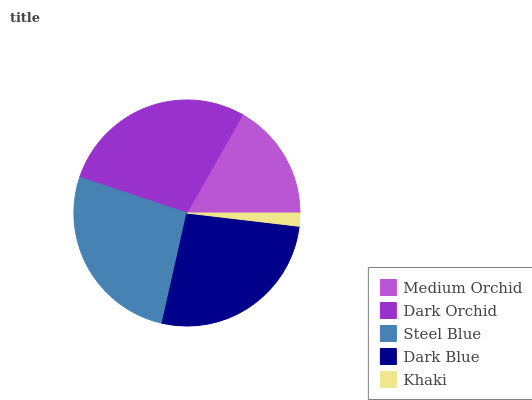Is Khaki the minimum?
Answer yes or no. Yes. Is Dark Orchid the maximum?
Answer yes or no. Yes. Is Steel Blue the minimum?
Answer yes or no. No. Is Steel Blue the maximum?
Answer yes or no. No. Is Dark Orchid greater than Steel Blue?
Answer yes or no. Yes. Is Steel Blue less than Dark Orchid?
Answer yes or no. Yes. Is Steel Blue greater than Dark Orchid?
Answer yes or no. No. Is Dark Orchid less than Steel Blue?
Answer yes or no. No. Is Steel Blue the high median?
Answer yes or no. Yes. Is Steel Blue the low median?
Answer yes or no. Yes. Is Dark Blue the high median?
Answer yes or no. No. Is Khaki the low median?
Answer yes or no. No. 